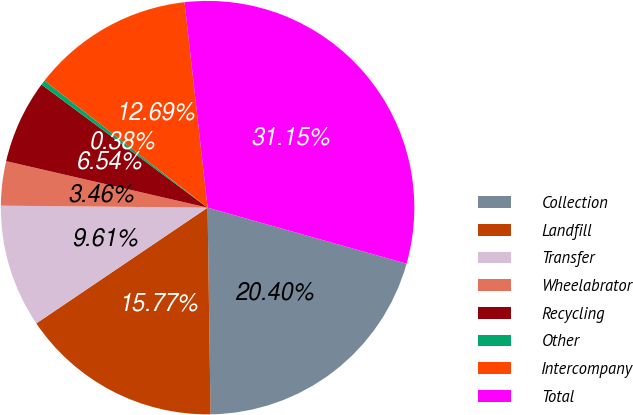<chart> <loc_0><loc_0><loc_500><loc_500><pie_chart><fcel>Collection<fcel>Landfill<fcel>Transfer<fcel>Wheelabrator<fcel>Recycling<fcel>Other<fcel>Intercompany<fcel>Total<nl><fcel>20.4%<fcel>15.77%<fcel>9.61%<fcel>3.46%<fcel>6.54%<fcel>0.38%<fcel>12.69%<fcel>31.15%<nl></chart> 